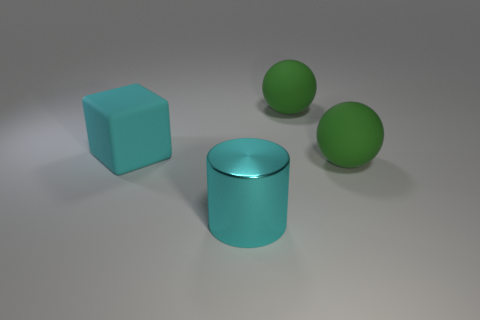What number of green rubber spheres are the same size as the cyan rubber thing?
Offer a very short reply. 2. There is a big metallic thing that is the same color as the big block; what shape is it?
Ensure brevity in your answer.  Cylinder. Does the matte ball in front of the large cyan block have the same color as the large matte object that is behind the cyan block?
Provide a succinct answer. Yes. What number of objects are behind the large cyan matte object?
Offer a very short reply. 1. There is a cube that is the same size as the metallic object; what color is it?
Offer a terse response. Cyan. Is the number of cyan rubber cubes that are right of the big cyan block less than the number of big rubber objects behind the metal cylinder?
Offer a very short reply. Yes. There is a cyan thing behind the big shiny thing; what is its shape?
Make the answer very short. Cube. Is the number of matte spheres greater than the number of small green metallic things?
Your response must be concise. Yes. Does the big shiny object on the right side of the cube have the same color as the cube?
Your answer should be compact. Yes. What number of objects are either big cyan objects that are on the left side of the metallic cylinder or large objects right of the cyan metallic cylinder?
Give a very brief answer. 3. 